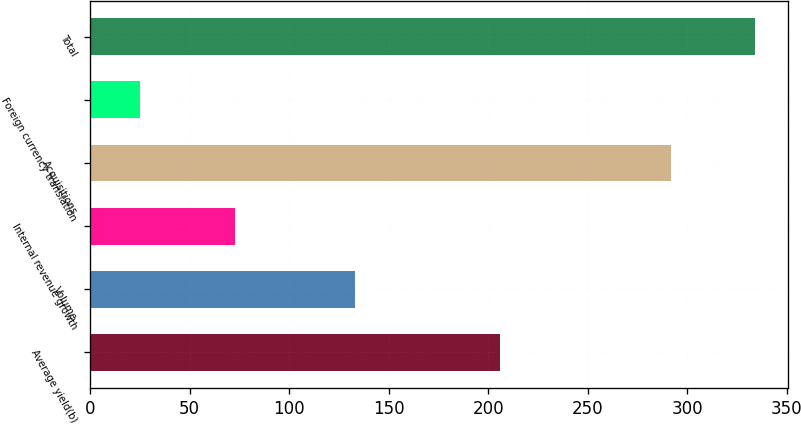<chart> <loc_0><loc_0><loc_500><loc_500><bar_chart><fcel>Average yield(b)<fcel>Volume<fcel>Internal revenue growth<fcel>Acquisitions<fcel>Foreign currency translation<fcel>Total<nl><fcel>206<fcel>133<fcel>73<fcel>292<fcel>25<fcel>334<nl></chart> 